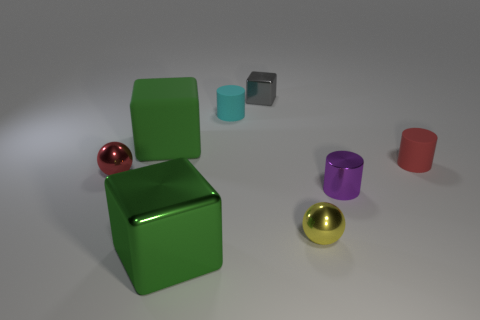Add 1 big cyan objects. How many objects exist? 9 Subtract all cubes. How many objects are left? 5 Subtract 0 cyan blocks. How many objects are left? 8 Subtract all green things. Subtract all small red objects. How many objects are left? 4 Add 6 rubber cubes. How many rubber cubes are left? 7 Add 8 gray metallic things. How many gray metallic things exist? 9 